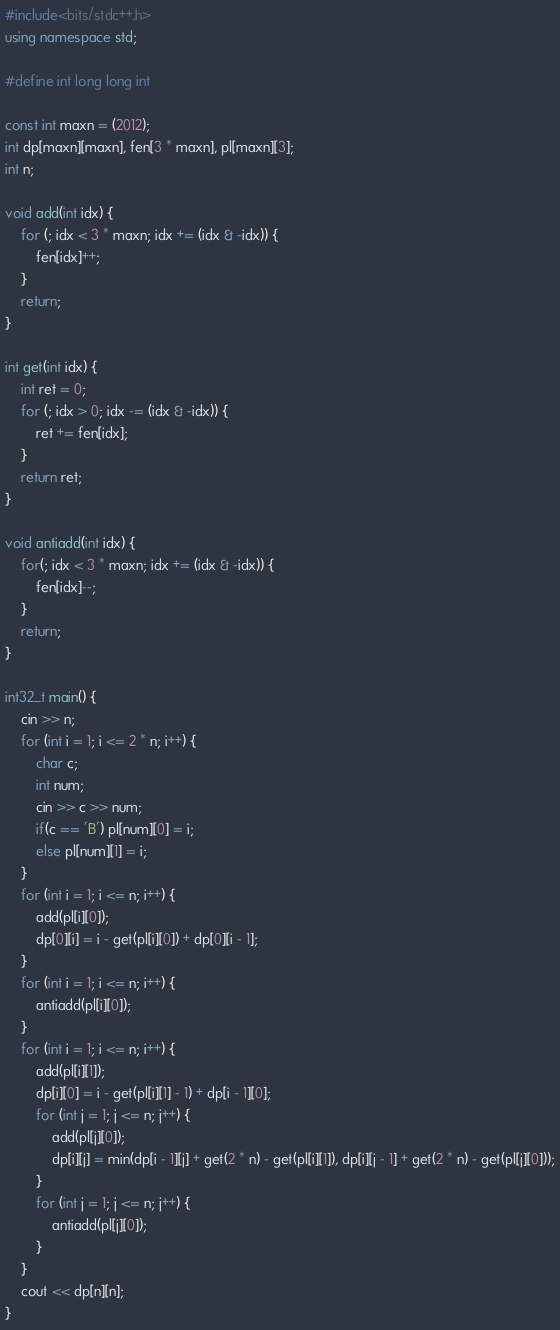<code> <loc_0><loc_0><loc_500><loc_500><_C++_>#include<bits/stdc++.h>
using namespace std;

#define int long long int

const int maxn = (2012);
int dp[maxn][maxn], fen[3 * maxn], pl[maxn][3];
int n;

void add(int idx) {
	for (; idx < 3 * maxn; idx += (idx & -idx)) {
		fen[idx]++;
	}
	return;
}

int get(int idx) {
	int ret = 0;
	for (; idx > 0; idx -= (idx & -idx)) {
		ret += fen[idx];
	}
	return ret;
}

void antiadd(int idx) {
	for(; idx < 3 * maxn; idx += (idx & -idx)) {
		fen[idx]--;
	}
	return;
}

int32_t main() {
	cin >> n;
	for (int i = 1; i <= 2 * n; i++) {
		char c;
		int num;
		cin >> c >> num;
		if(c == 'B') pl[num][0] = i;
		else pl[num][1] = i;
	}
	for (int i = 1; i <= n; i++) {
		add(pl[i][0]);
		dp[0][i] = i - get(pl[i][0]) + dp[0][i - 1];
	}
	for (int i = 1; i <= n; i++) {
		antiadd(pl[i][0]);
	}
	for (int i = 1; i <= n; i++) {
  		add(pl[i][1]);
  		dp[i][0] = i - get(pl[i][1] - 1) + dp[i - 1][0];
		for (int j = 1; j <= n; j++) {
   			add(pl[j][0]);
			dp[i][j] = min(dp[i - 1][j] + get(2 * n) - get(pl[i][1]), dp[i][j - 1] + get(2 * n) - get(pl[j][0]));
		}
		for (int j = 1; j <= n; j++) {
			antiadd(pl[j][0]);
		}
	}
	cout << dp[n][n];
}</code> 